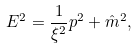<formula> <loc_0><loc_0><loc_500><loc_500>E ^ { 2 } = \frac { 1 } { \xi ^ { 2 } } p ^ { 2 } + \hat { m } ^ { 2 } ,</formula> 